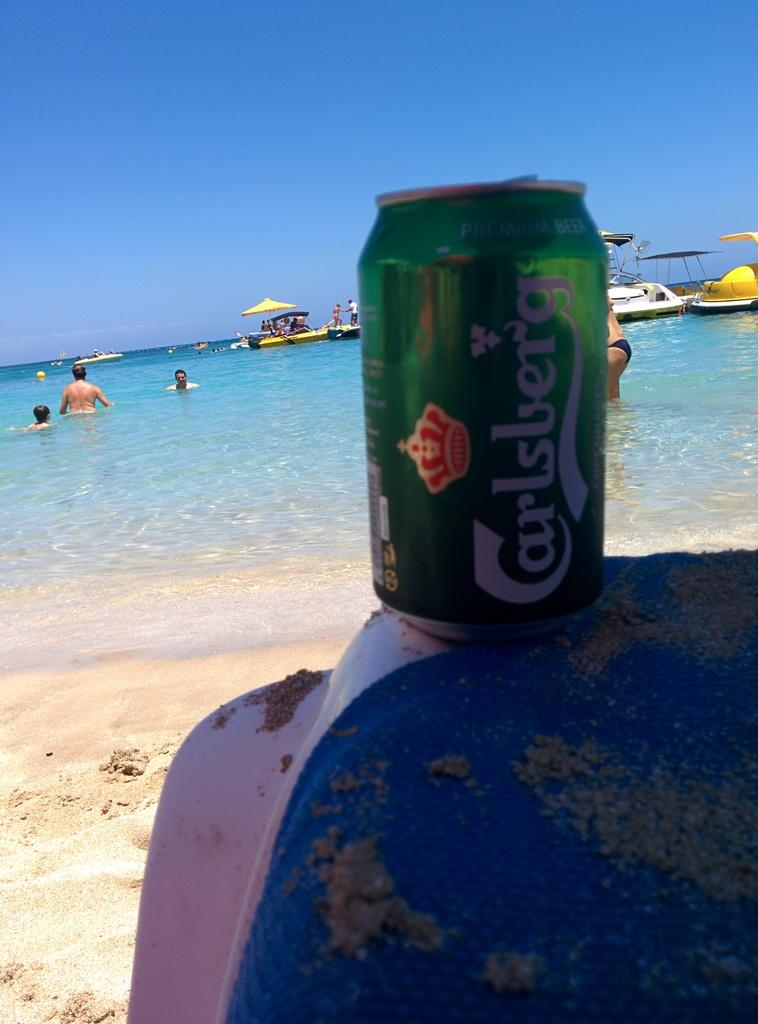<image>
Write a terse but informative summary of the picture. A can of Carlsberg beer is on the edge of a chair facing the ocean. 